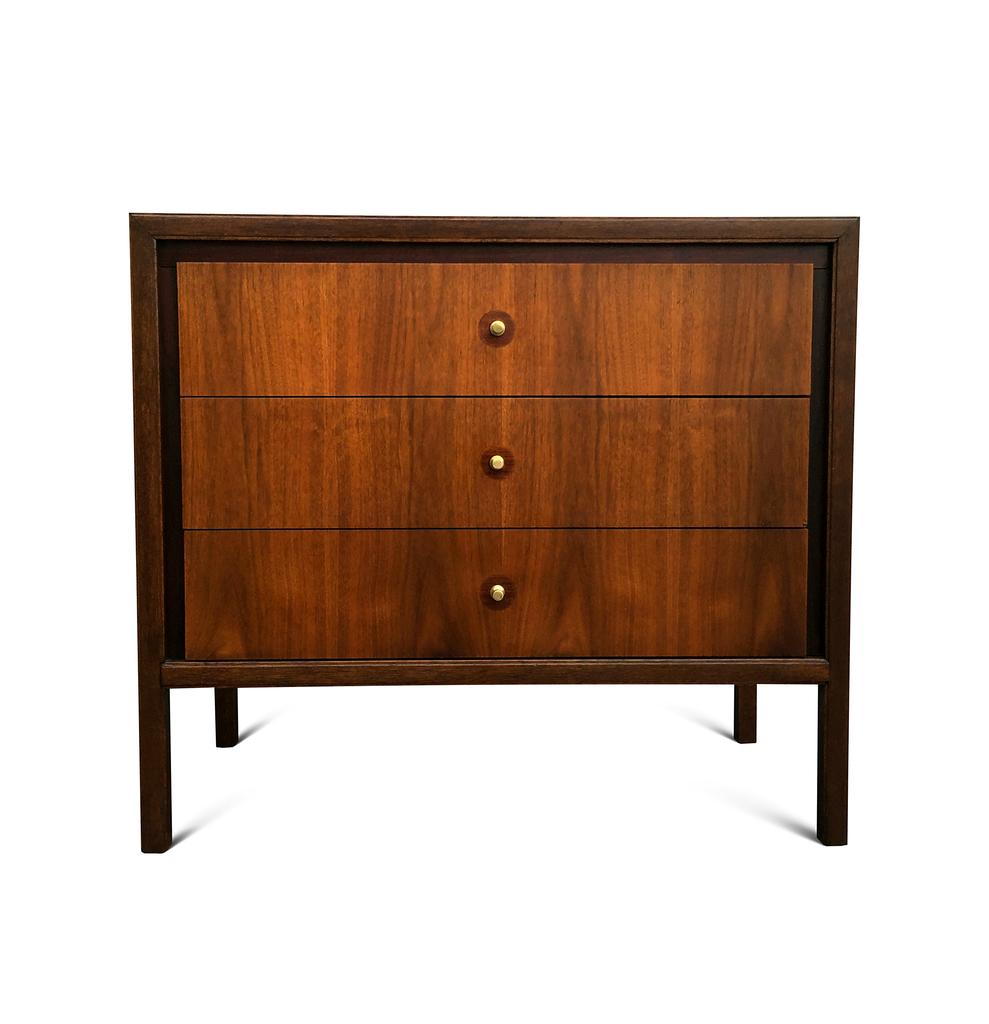What piece of furniture is present in the image? There is a table in the image. How many drawers are on the table? The table has three drawers. What type of stem is visible on the table in the image? There is no stem visible on the table in the image. What disease is being treated on the table in the image? There is no indication of a disease or treatment in the image; it only shows a table with three drawers. 